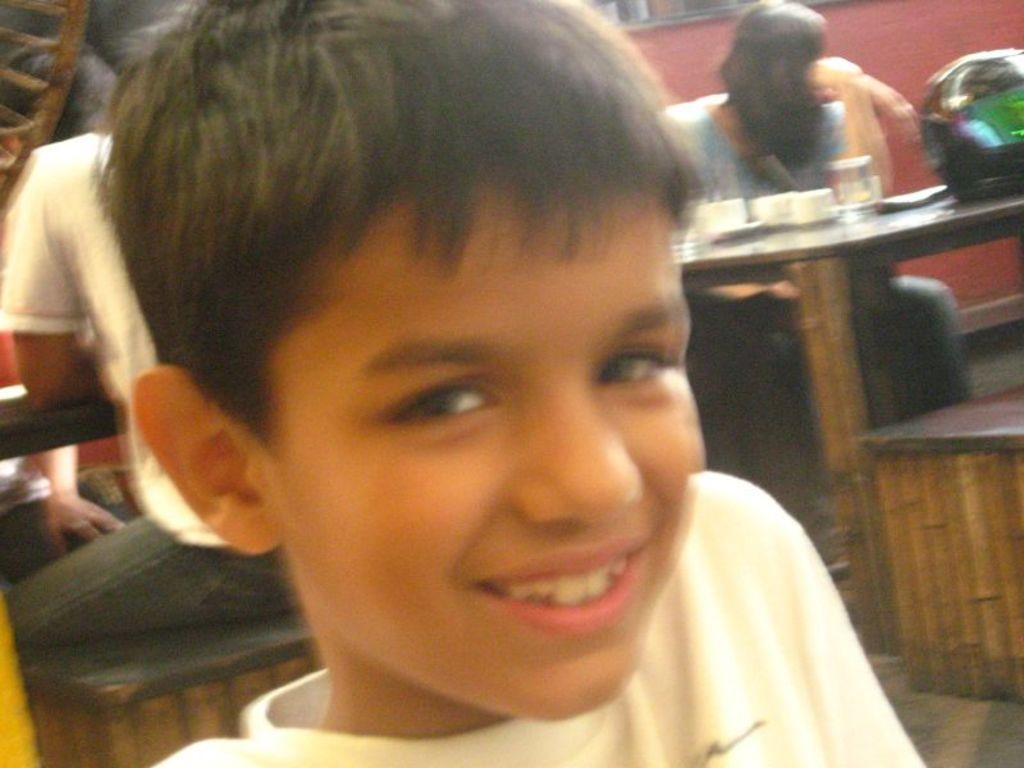What is the main subject in the foreground of the image? There is a boy in the foreground of the image. What is the boy's expression in the image? The boy is smiling in the image. What type of furniture can be seen in the background of the image? There are tables and benches in the background of the image. Are there any other people visible in the image? Yes, there are people in the background of the image. Can you see any tigers on the farm in the image? There is no farm or tiger present in the image. What type of quiver is the boy holding in the image? The boy is not holding a quiver in the image; he is simply smiling. 